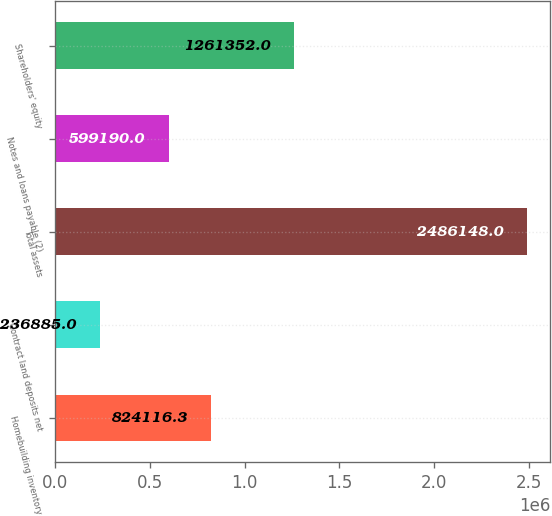<chart> <loc_0><loc_0><loc_500><loc_500><bar_chart><fcel>Homebuilding inventory<fcel>Contract land deposits net<fcel>Total assets<fcel>Notes and loans payable (2)<fcel>Shareholders' equity<nl><fcel>824116<fcel>236885<fcel>2.48615e+06<fcel>599190<fcel>1.26135e+06<nl></chart> 